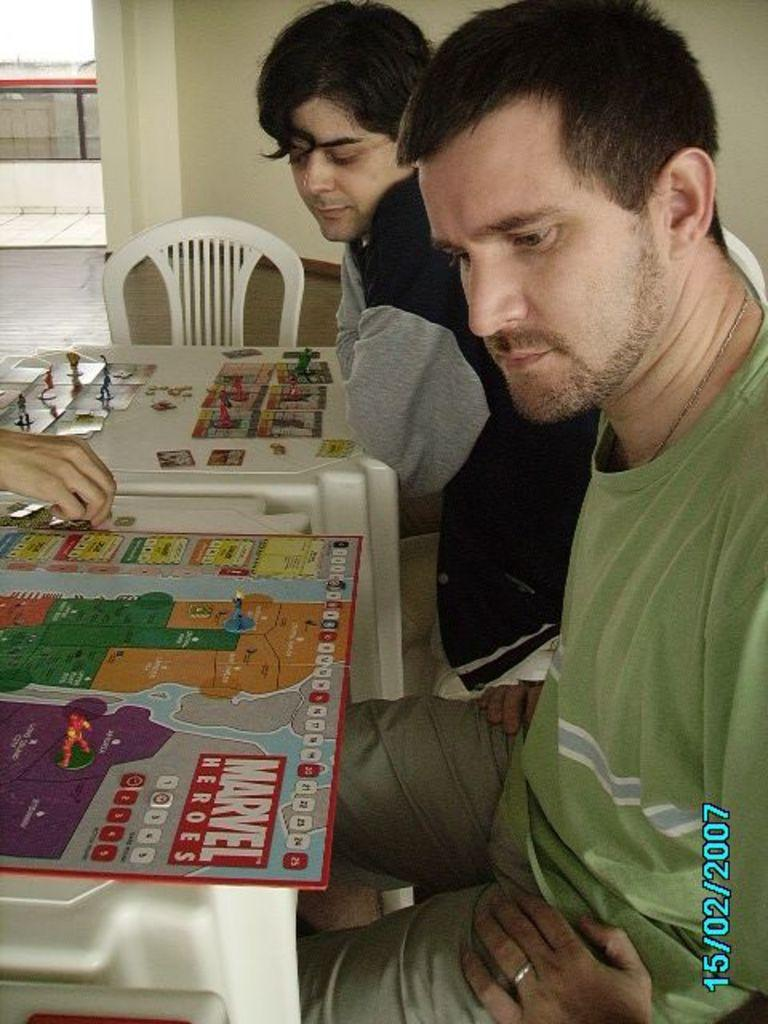How many people are present in the image? There are two people in the image. Can you describe any visible body parts of the people? One hand of a person is visible in the image. What can be seen in the background of the image? There is a chair and two tables in the background of the image. What type of reaction can be seen from the dinosaurs in the image? There are no dinosaurs present in the image, so it is not possible to determine their reactions. 